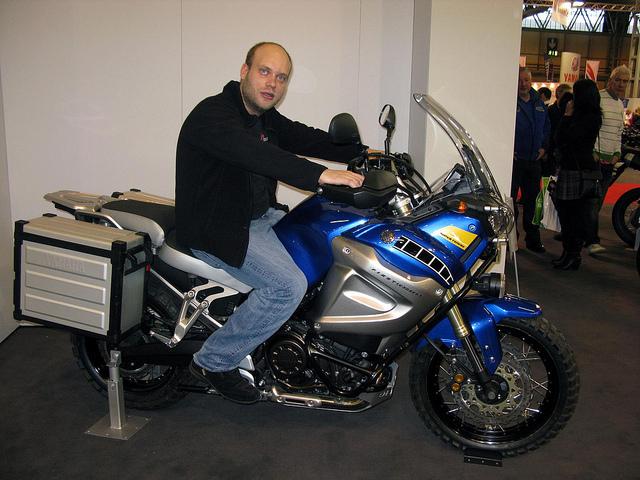What tool is the motorcyclist carrying?
Write a very short answer. Toolbox. Is this bike for sale?
Give a very brief answer. No. Is there a star on the motorcycle?
Answer briefly. No. Where is the bicycle?
Give a very brief answer. Garage. Who make of motorcycle is this?
Answer briefly. Yamaha. What material is the seat made out of?
Answer briefly. Leather. What color is the bike?
Short answer required. Blue. What is this man's profession?
Be succinct. Cannot tell. IS this vehicle outside?
Write a very short answer. No. Is this an antique motorcycle?
Be succinct. No. What kind of pants is the man wearing?
Quick response, please. Jeans. What is the man sitting on?
Quick response, please. Motorcycle. 